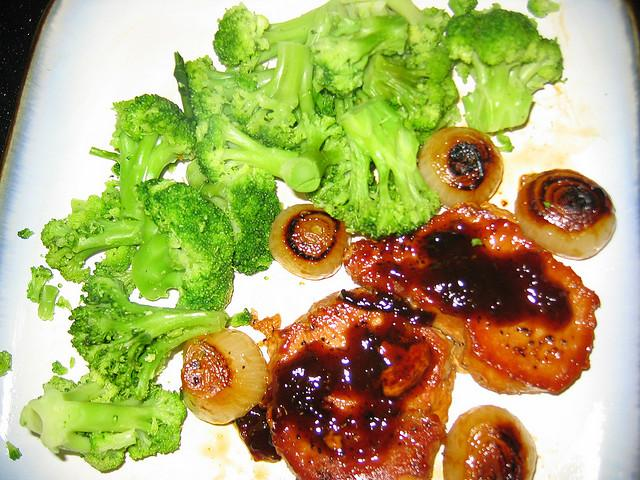What are the little round vegetables called? onions 